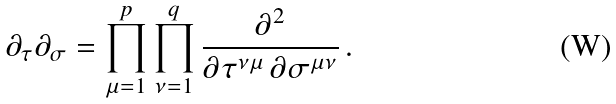<formula> <loc_0><loc_0><loc_500><loc_500>\partial _ { \tau } \partial _ { \sigma } = \prod _ { \mu = 1 } ^ { p } \prod _ { \nu = 1 } ^ { q } \frac { \partial ^ { 2 } } { \partial \tau ^ { \nu \mu } \, \partial \sigma ^ { \mu \nu } } \, .</formula> 